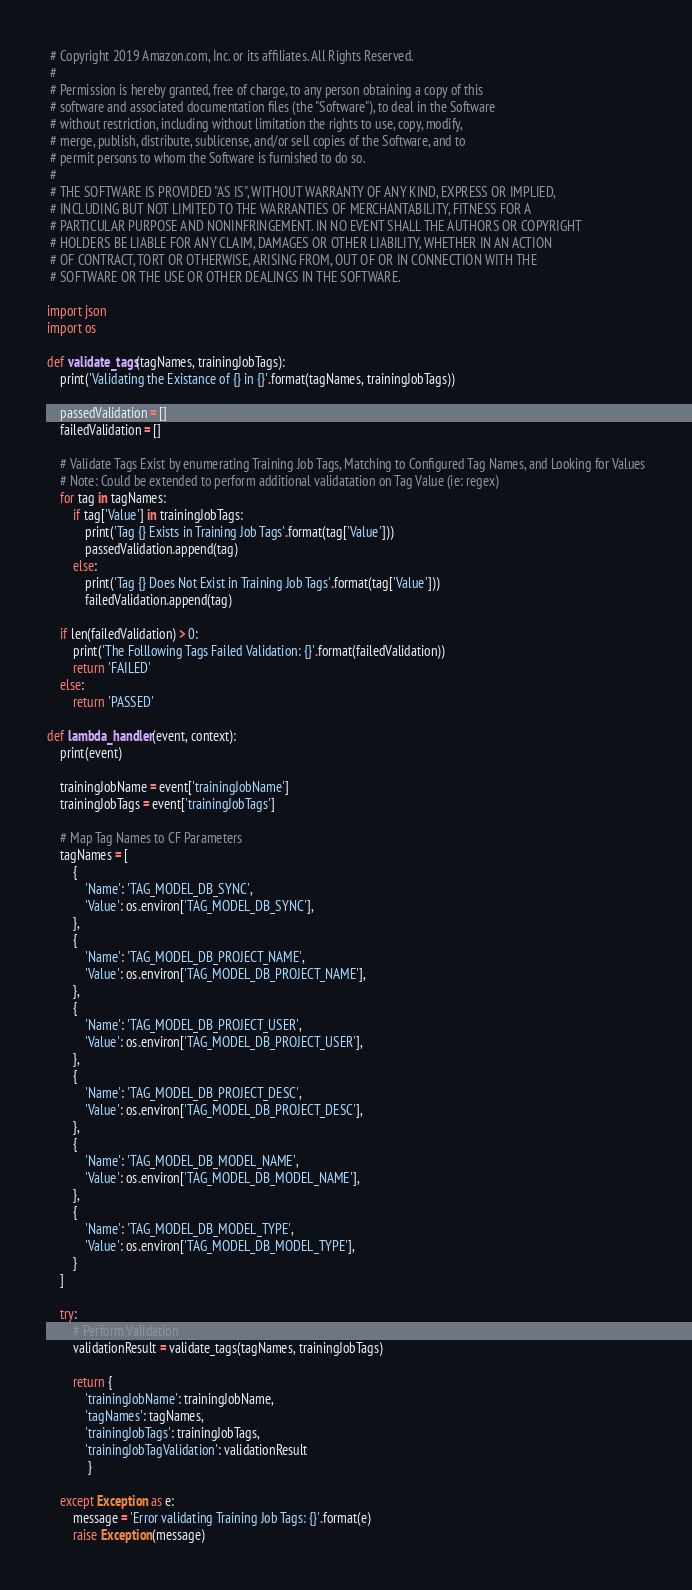Convert code to text. <code><loc_0><loc_0><loc_500><loc_500><_Python_> # Copyright 2019 Amazon.com, Inc. or its affiliates. All Rights Reserved.
 #
 # Permission is hereby granted, free of charge, to any person obtaining a copy of this
 # software and associated documentation files (the "Software"), to deal in the Software
 # without restriction, including without limitation the rights to use, copy, modify,
 # merge, publish, distribute, sublicense, and/or sell copies of the Software, and to
 # permit persons to whom the Software is furnished to do so.
 #
 # THE SOFTWARE IS PROVIDED "AS IS", WITHOUT WARRANTY OF ANY KIND, EXPRESS OR IMPLIED,
 # INCLUDING BUT NOT LIMITED TO THE WARRANTIES OF MERCHANTABILITY, FITNESS FOR A
 # PARTICULAR PURPOSE AND NONINFRINGEMENT. IN NO EVENT SHALL THE AUTHORS OR COPYRIGHT
 # HOLDERS BE LIABLE FOR ANY CLAIM, DAMAGES OR OTHER LIABILITY, WHETHER IN AN ACTION
 # OF CONTRACT, TORT OR OTHERWISE, ARISING FROM, OUT OF OR IN CONNECTION WITH THE
 # SOFTWARE OR THE USE OR OTHER DEALINGS IN THE SOFTWARE.

import json
import os

def validate_tags(tagNames, trainingJobTags):
    print('Validating the Existance of {} in {}'.format(tagNames, trainingJobTags))
    
    passedValidation = []
    failedValidation = []

    # Validate Tags Exist by enumerating Training Job Tags, Matching to Configured Tag Names, and Looking for Values
    # Note: Could be extended to perform additional validatation on Tag Value (ie: regex)
    for tag in tagNames:
        if tag['Value'] in trainingJobTags:
            print('Tag {} Exists in Training Job Tags'.format(tag['Value']))
            passedValidation.append(tag)
        else:
            print('Tag {} Does Not Exist in Training Job Tags'.format(tag['Value']))
            failedValidation.append(tag)

    if len(failedValidation) > 0:
        print('The Folllowing Tags Failed Validation: {}'.format(failedValidation))
        return 'FAILED'
    else:
        return 'PASSED'

def lambda_handler(event, context):
    print(event)

    trainingJobName = event['trainingJobName']
    trainingJobTags = event['trainingJobTags']

    # Map Tag Names to CF Parameters 
    tagNames = [
        {
            'Name': 'TAG_MODEL_DB_SYNC',
            'Value': os.environ['TAG_MODEL_DB_SYNC'],
        },
        {
            'Name': 'TAG_MODEL_DB_PROJECT_NAME',
            'Value': os.environ['TAG_MODEL_DB_PROJECT_NAME'],
        },
        {
            'Name': 'TAG_MODEL_DB_PROJECT_USER',
            'Value': os.environ['TAG_MODEL_DB_PROJECT_USER'],
        },
        {
            'Name': 'TAG_MODEL_DB_PROJECT_DESC',
            'Value': os.environ['TAG_MODEL_DB_PROJECT_DESC'],
        },
        {
            'Name': 'TAG_MODEL_DB_MODEL_NAME',
            'Value': os.environ['TAG_MODEL_DB_MODEL_NAME'],
        },
        {
            'Name': 'TAG_MODEL_DB_MODEL_TYPE',
            'Value': os.environ['TAG_MODEL_DB_MODEL_TYPE'],
        }
    ]
 
    try:
        # Perform Validation
        validationResult = validate_tags(tagNames, trainingJobTags)

        return {
            'trainingJobName': trainingJobName,
            'tagNames': tagNames,
            'trainingJobTags': trainingJobTags,
            'trainingJobTagValidation': validationResult
             }  

    except Exception as e:
        message = 'Error validating Training Job Tags: {}'.format(e)
        raise Exception(message)</code> 